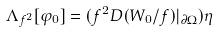<formula> <loc_0><loc_0><loc_500><loc_500>\Lambda _ { f ^ { 2 } } [ \varphi _ { 0 } ] = ( f ^ { 2 } D ( W _ { 0 } / f ) | _ { \partial \Omega } ) \eta</formula> 